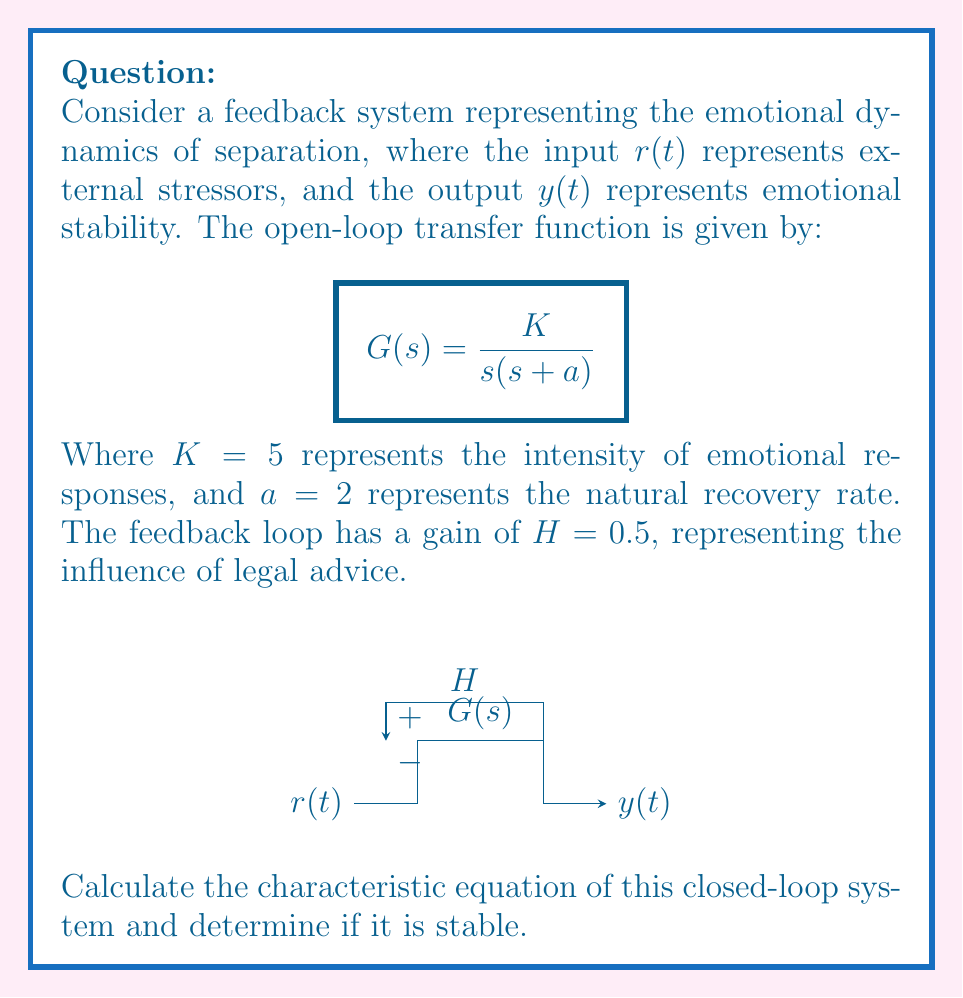Provide a solution to this math problem. To determine the stability of the closed-loop system, we need to follow these steps:

1) First, let's recall the general form of the closed-loop transfer function:

   $$T(s) = \frac{G(s)}{1 + G(s)H(s)}$$

2) The characteristic equation is the denominator of this transfer function set to zero:

   $$1 + G(s)H(s) = 0$$

3) Substituting our given $G(s)$ and $H$:

   $$1 + \frac{K}{s(s+a)} \cdot 0.5 = 0$$

4) Multiply both sides by $s(s+a)$:

   $$s(s+a) + 0.5K = 0$$

5) Expand the equation:

   $$s^2 + as + 0.5K = 0$$

6) Substitute the given values $K = 5$ and $a = 2$:

   $$s^2 + 2s + 2.5 = 0$$

7) This is our characteristic equation. To determine stability, we can use the Routh-Hurwitz criterion. For a second-order system $as^2 + bs + c = 0$, the system is stable if and only if $a > 0$, $b > 0$, and $c > 0$.

8) In our case, $a = 1$, $b = 2$, and $c = 2.5$. All coefficients are positive, so the system is stable.

Alternatively, we could solve for the roots of the characteristic equation:

$$s = \frac{-2 \pm \sqrt{4 - 4(1)(2.5)}}{2(1)} = -1 \pm j\sqrt{1.5}$$

Both roots have negative real parts, confirming stability.
Answer: The system is stable. 